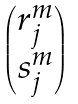<formula> <loc_0><loc_0><loc_500><loc_500>\begin{pmatrix} r ^ { m } _ { j } \\ s ^ { m } _ { j } \end{pmatrix}</formula> 